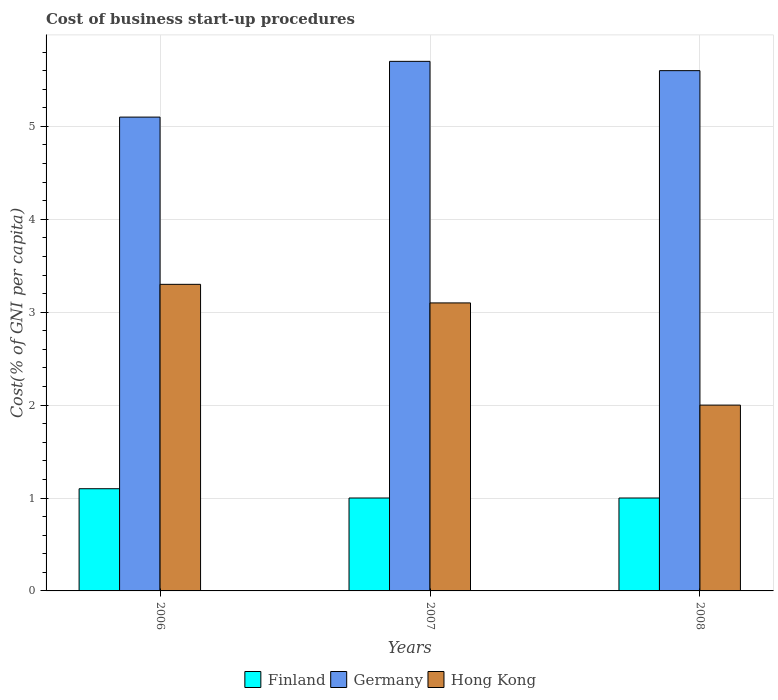How many different coloured bars are there?
Your response must be concise. 3. How many groups of bars are there?
Your answer should be compact. 3. Are the number of bars per tick equal to the number of legend labels?
Your answer should be very brief. Yes. How many bars are there on the 3rd tick from the left?
Offer a terse response. 3. What is the label of the 3rd group of bars from the left?
Give a very brief answer. 2008. In how many cases, is the number of bars for a given year not equal to the number of legend labels?
Your answer should be very brief. 0. What is the difference between the cost of business start-up procedures in Finland in 2006 and that in 2008?
Make the answer very short. 0.1. What is the difference between the cost of business start-up procedures in Finland in 2008 and the cost of business start-up procedures in Germany in 2007?
Provide a succinct answer. -4.7. What is the average cost of business start-up procedures in Hong Kong per year?
Offer a terse response. 2.8. In the year 2008, what is the difference between the cost of business start-up procedures in Germany and cost of business start-up procedures in Finland?
Ensure brevity in your answer.  4.6. In how many years, is the cost of business start-up procedures in Germany greater than 2.2 %?
Ensure brevity in your answer.  3. What is the ratio of the cost of business start-up procedures in Germany in 2006 to that in 2008?
Make the answer very short. 0.91. Is the cost of business start-up procedures in Hong Kong in 2007 less than that in 2008?
Your response must be concise. No. What is the difference between the highest and the second highest cost of business start-up procedures in Hong Kong?
Offer a very short reply. 0.2. What is the difference between the highest and the lowest cost of business start-up procedures in Germany?
Give a very brief answer. 0.6. What does the 2nd bar from the left in 2007 represents?
Ensure brevity in your answer.  Germany. What does the 2nd bar from the right in 2008 represents?
Your answer should be compact. Germany. Are all the bars in the graph horizontal?
Offer a terse response. No. Does the graph contain any zero values?
Provide a succinct answer. No. Does the graph contain grids?
Offer a very short reply. Yes. How many legend labels are there?
Offer a terse response. 3. What is the title of the graph?
Make the answer very short. Cost of business start-up procedures. What is the label or title of the X-axis?
Provide a short and direct response. Years. What is the label or title of the Y-axis?
Provide a short and direct response. Cost(% of GNI per capita). What is the Cost(% of GNI per capita) in Germany in 2006?
Ensure brevity in your answer.  5.1. What is the Cost(% of GNI per capita) of Finland in 2007?
Keep it short and to the point. 1. What is the Cost(% of GNI per capita) in Hong Kong in 2007?
Your answer should be compact. 3.1. What is the Cost(% of GNI per capita) in Germany in 2008?
Provide a succinct answer. 5.6. What is the Cost(% of GNI per capita) in Hong Kong in 2008?
Ensure brevity in your answer.  2. Across all years, what is the maximum Cost(% of GNI per capita) in Hong Kong?
Your answer should be very brief. 3.3. Across all years, what is the minimum Cost(% of GNI per capita) of Finland?
Offer a terse response. 1. What is the total Cost(% of GNI per capita) in Finland in the graph?
Offer a very short reply. 3.1. What is the difference between the Cost(% of GNI per capita) in Finland in 2006 and that in 2007?
Offer a very short reply. 0.1. What is the difference between the Cost(% of GNI per capita) of Germany in 2006 and that in 2007?
Your answer should be very brief. -0.6. What is the difference between the Cost(% of GNI per capita) in Hong Kong in 2006 and that in 2007?
Your answer should be very brief. 0.2. What is the difference between the Cost(% of GNI per capita) in Hong Kong in 2006 and that in 2008?
Give a very brief answer. 1.3. What is the difference between the Cost(% of GNI per capita) of Germany in 2007 and that in 2008?
Your answer should be compact. 0.1. What is the difference between the Cost(% of GNI per capita) of Hong Kong in 2007 and that in 2008?
Give a very brief answer. 1.1. What is the difference between the Cost(% of GNI per capita) in Germany in 2006 and the Cost(% of GNI per capita) in Hong Kong in 2008?
Your answer should be very brief. 3.1. What is the difference between the Cost(% of GNI per capita) of Finland in 2007 and the Cost(% of GNI per capita) of Germany in 2008?
Your response must be concise. -4.6. What is the difference between the Cost(% of GNI per capita) of Finland in 2007 and the Cost(% of GNI per capita) of Hong Kong in 2008?
Offer a very short reply. -1. What is the difference between the Cost(% of GNI per capita) in Germany in 2007 and the Cost(% of GNI per capita) in Hong Kong in 2008?
Ensure brevity in your answer.  3.7. What is the average Cost(% of GNI per capita) in Finland per year?
Your response must be concise. 1.03. What is the average Cost(% of GNI per capita) in Germany per year?
Give a very brief answer. 5.47. What is the average Cost(% of GNI per capita) in Hong Kong per year?
Keep it short and to the point. 2.8. In the year 2006, what is the difference between the Cost(% of GNI per capita) of Finland and Cost(% of GNI per capita) of Germany?
Your answer should be very brief. -4. In the year 2006, what is the difference between the Cost(% of GNI per capita) of Germany and Cost(% of GNI per capita) of Hong Kong?
Your answer should be very brief. 1.8. In the year 2007, what is the difference between the Cost(% of GNI per capita) of Finland and Cost(% of GNI per capita) of Hong Kong?
Provide a short and direct response. -2.1. In the year 2008, what is the difference between the Cost(% of GNI per capita) of Germany and Cost(% of GNI per capita) of Hong Kong?
Your answer should be very brief. 3.6. What is the ratio of the Cost(% of GNI per capita) in Finland in 2006 to that in 2007?
Ensure brevity in your answer.  1.1. What is the ratio of the Cost(% of GNI per capita) of Germany in 2006 to that in 2007?
Your answer should be very brief. 0.89. What is the ratio of the Cost(% of GNI per capita) of Hong Kong in 2006 to that in 2007?
Provide a succinct answer. 1.06. What is the ratio of the Cost(% of GNI per capita) of Finland in 2006 to that in 2008?
Offer a very short reply. 1.1. What is the ratio of the Cost(% of GNI per capita) in Germany in 2006 to that in 2008?
Provide a succinct answer. 0.91. What is the ratio of the Cost(% of GNI per capita) in Hong Kong in 2006 to that in 2008?
Offer a terse response. 1.65. What is the ratio of the Cost(% of GNI per capita) in Finland in 2007 to that in 2008?
Give a very brief answer. 1. What is the ratio of the Cost(% of GNI per capita) of Germany in 2007 to that in 2008?
Provide a short and direct response. 1.02. What is the ratio of the Cost(% of GNI per capita) of Hong Kong in 2007 to that in 2008?
Provide a succinct answer. 1.55. What is the difference between the highest and the second highest Cost(% of GNI per capita) in Finland?
Ensure brevity in your answer.  0.1. What is the difference between the highest and the second highest Cost(% of GNI per capita) of Germany?
Give a very brief answer. 0.1. What is the difference between the highest and the second highest Cost(% of GNI per capita) in Hong Kong?
Ensure brevity in your answer.  0.2. What is the difference between the highest and the lowest Cost(% of GNI per capita) of Finland?
Give a very brief answer. 0.1. What is the difference between the highest and the lowest Cost(% of GNI per capita) in Germany?
Your answer should be very brief. 0.6. 